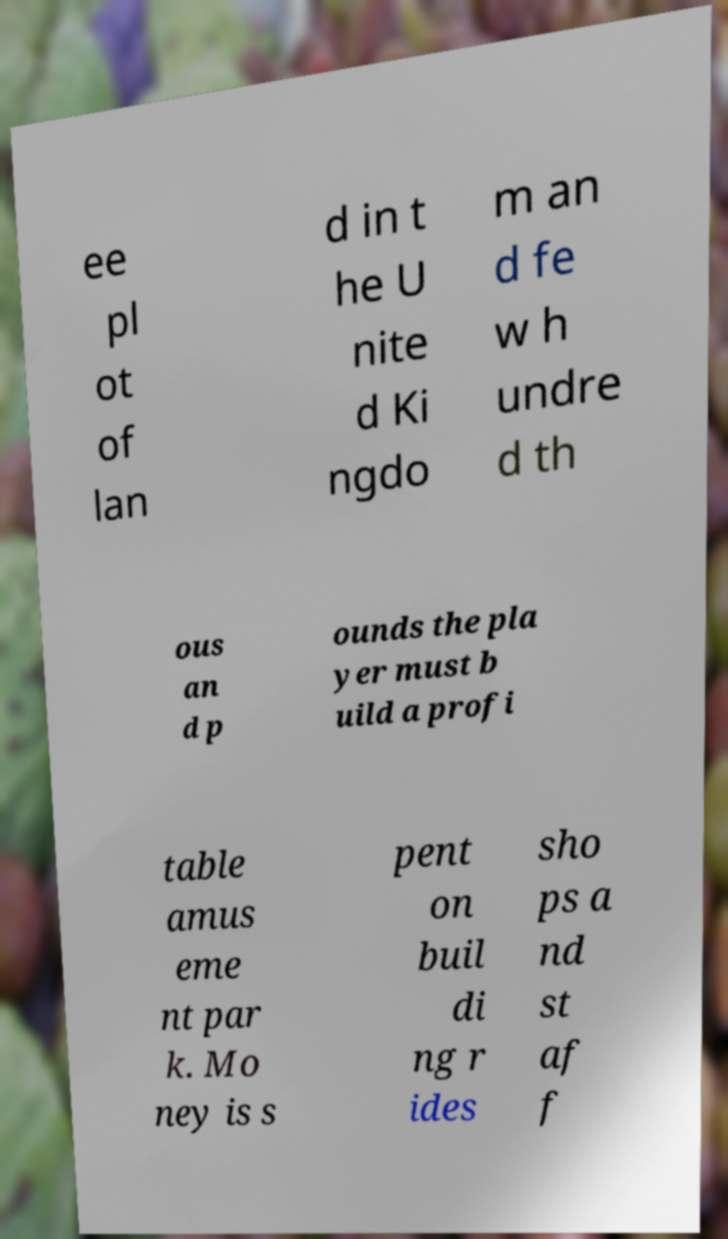Can you read and provide the text displayed in the image?This photo seems to have some interesting text. Can you extract and type it out for me? ee pl ot of lan d in t he U nite d Ki ngdo m an d fe w h undre d th ous an d p ounds the pla yer must b uild a profi table amus eme nt par k. Mo ney is s pent on buil di ng r ides sho ps a nd st af f 